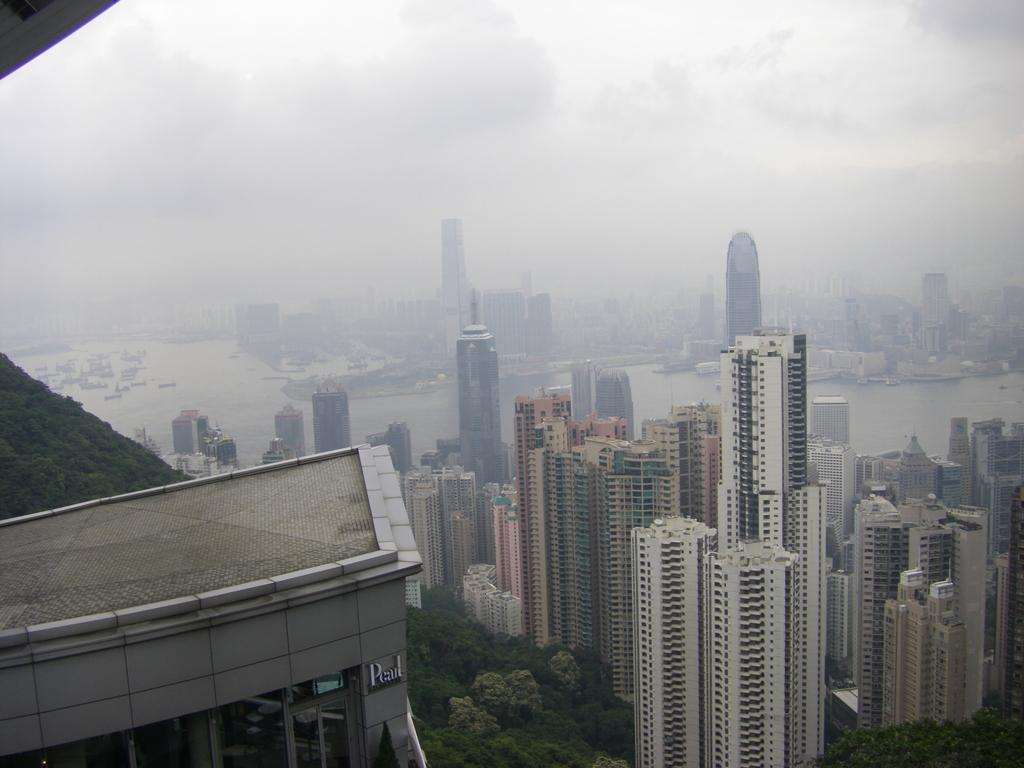What structure is located on the left side of the image in the foreground? There is a building on the left side of the image in the foreground. What can be seen behind the building? There is greenery behind the building. What type of structures are visible in the background? Skyscrapers and other buildings are visible in the background. What natural element is present in the background? Water is present in the background. What type of vehicles can be seen in the background? Ships are visible in the background. What part of the sky is visible in the background? The sky is visible in the background. How many spiders are crawling on the yard in the image? There is no yard or spiders present in the image. What type of passenger is sitting on the building in the image? There is no passenger sitting on the building in the image; it is a structure with no people present. 